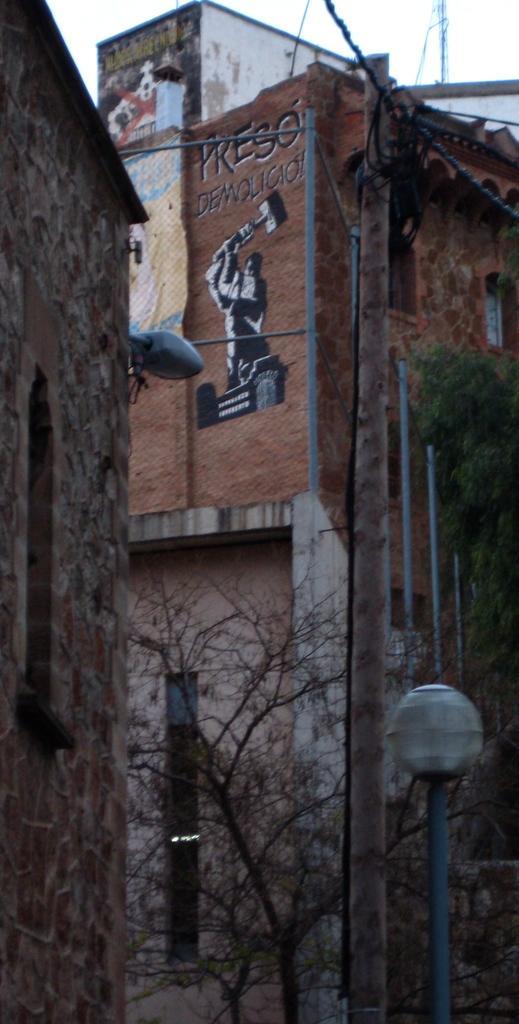Can you describe this image briefly? In front of the picture, we see the tree and the light pole. There are buildings and street lights in the background. On the right side, we see a tree. At the top, we see the sky and the tower. 